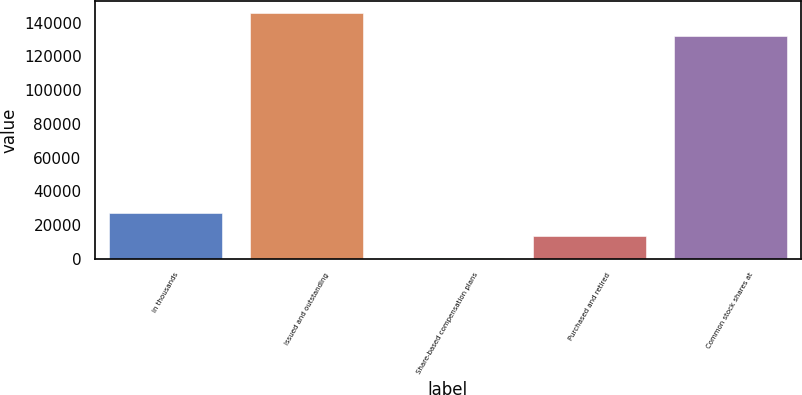Convert chart. <chart><loc_0><loc_0><loc_500><loc_500><bar_chart><fcel>in thousands<fcel>issued and outstanding<fcel>Share-based compensation plans<fcel>Purchased and retired<fcel>Common stock shares at<nl><fcel>26863.8<fcel>145508<fcel>495<fcel>13679.4<fcel>132324<nl></chart> 